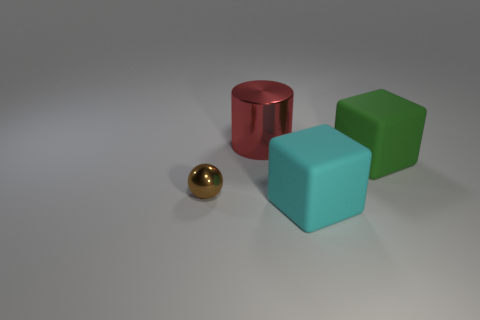There is a big object that is both left of the large green cube and in front of the red shiny cylinder; what color is it?
Offer a terse response. Cyan. What is the shape of the metallic thing in front of the shiny thing behind the cube that is to the right of the cyan thing?
Provide a succinct answer. Sphere. What color is the other large rubber object that is the same shape as the cyan object?
Ensure brevity in your answer.  Green. There is a rubber object behind the object that is in front of the metal ball; what color is it?
Give a very brief answer. Green. What is the size of the green rubber thing that is the same shape as the cyan thing?
Your response must be concise. Large. What number of other large things have the same material as the red object?
Keep it short and to the point. 0. How many big green rubber objects are behind the rubber block in front of the brown metallic sphere?
Your answer should be compact. 1. Are there any cyan rubber cubes in front of the tiny shiny ball?
Your response must be concise. Yes. Is the shape of the rubber object that is in front of the green thing the same as  the red shiny object?
Your answer should be compact. No. How many tiny shiny things have the same color as the cylinder?
Make the answer very short. 0. 